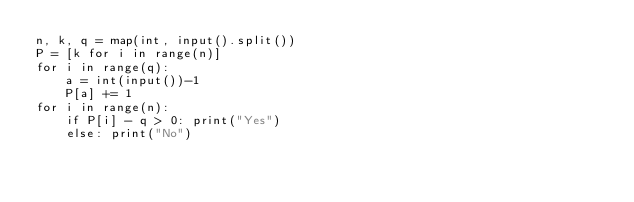Convert code to text. <code><loc_0><loc_0><loc_500><loc_500><_Python_>n, k, q = map(int, input().split())
P = [k for i in range(n)]
for i in range(q):
    a = int(input())-1
    P[a] += 1
for i in range(n):
    if P[i] - q > 0: print("Yes")
    else: print("No")</code> 